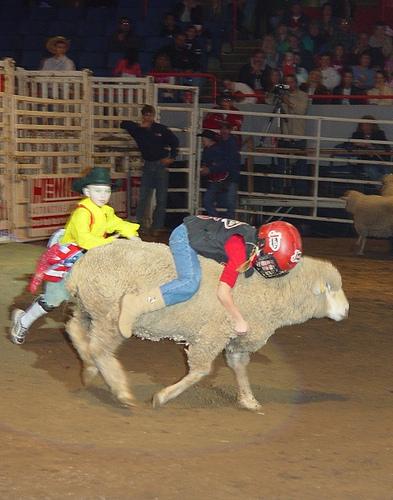Are the kids having fun?
Quick response, please. Yes. Why is the kid riding a sheep?
Short answer required. Rodeo. Why is this sheep moving in unpredictable, rapid movements?
Short answer required. Race. 